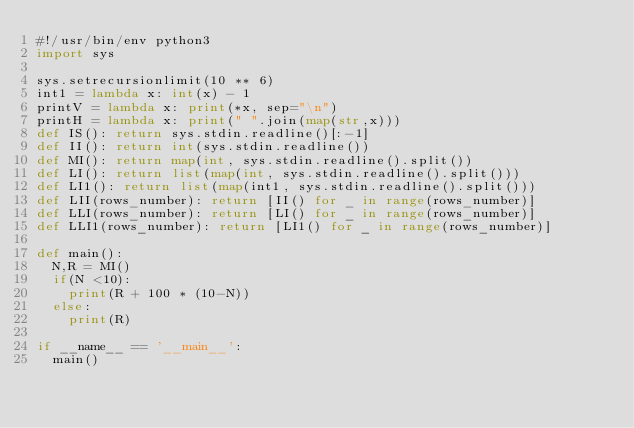Convert code to text. <code><loc_0><loc_0><loc_500><loc_500><_Python_>#!/usr/bin/env python3
import sys

sys.setrecursionlimit(10 ** 6)
int1 = lambda x: int(x) - 1
printV = lambda x: print(*x, sep="\n")
printH = lambda x: print(" ".join(map(str,x)))
def IS(): return sys.stdin.readline()[:-1]
def II(): return int(sys.stdin.readline())
def MI(): return map(int, sys.stdin.readline().split())
def LI(): return list(map(int, sys.stdin.readline().split()))
def LI1(): return list(map(int1, sys.stdin.readline().split()))
def LII(rows_number): return [II() for _ in range(rows_number)]
def LLI(rows_number): return [LI() for _ in range(rows_number)]
def LLI1(rows_number): return [LI1() for _ in range(rows_number)]

def main():
	N,R = MI()
	if(N <10):
		print(R + 100 * (10-N))
	else:
		print(R)

if __name__ == '__main__':
	main()</code> 